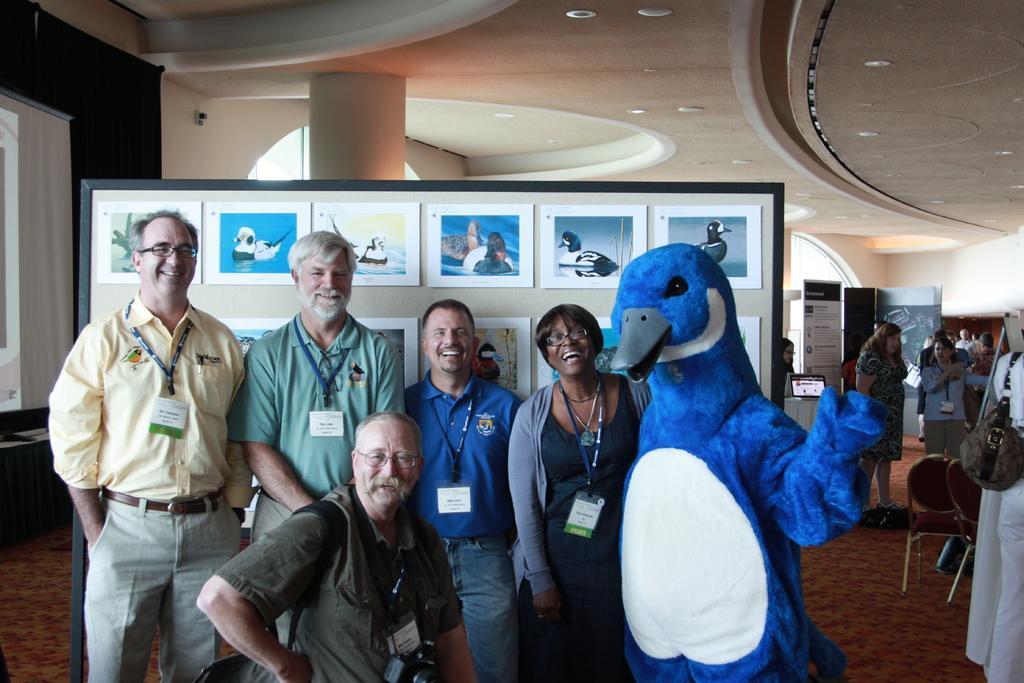Could you give a brief overview of what you see in this image? In this image we can see the inner view of a building and there are some people and among them few people smiling and posing for a photo. There is an object which looks like a toy and we can see a board with some pictures and there are some other objects in the room. 